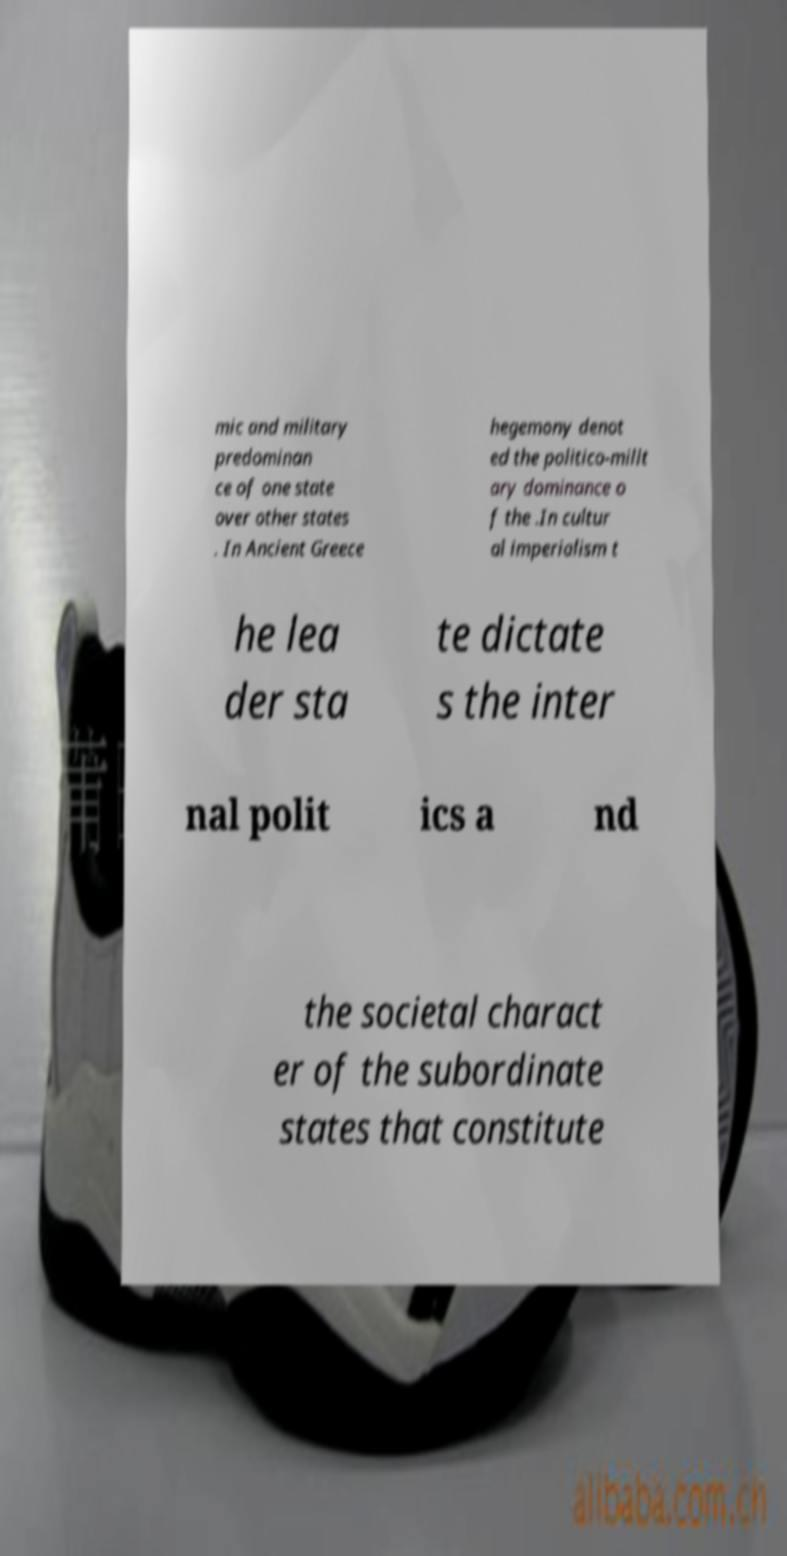Can you read and provide the text displayed in the image?This photo seems to have some interesting text. Can you extract and type it out for me? mic and military predominan ce of one state over other states . In Ancient Greece hegemony denot ed the politico-milit ary dominance o f the .In cultur al imperialism t he lea der sta te dictate s the inter nal polit ics a nd the societal charact er of the subordinate states that constitute 